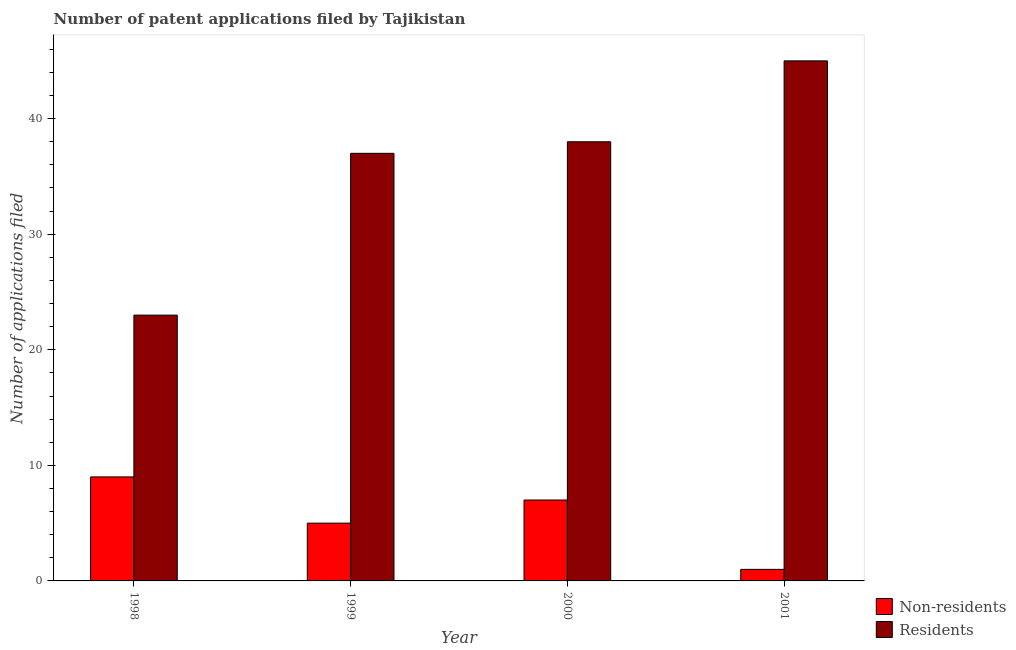How many different coloured bars are there?
Make the answer very short. 2. How many groups of bars are there?
Ensure brevity in your answer.  4. Are the number of bars per tick equal to the number of legend labels?
Ensure brevity in your answer.  Yes. How many bars are there on the 3rd tick from the left?
Give a very brief answer. 2. How many bars are there on the 4th tick from the right?
Make the answer very short. 2. What is the label of the 4th group of bars from the left?
Provide a short and direct response. 2001. What is the number of patent applications by non residents in 2001?
Your answer should be very brief. 1. Across all years, what is the maximum number of patent applications by non residents?
Ensure brevity in your answer.  9. Across all years, what is the minimum number of patent applications by non residents?
Provide a short and direct response. 1. In which year was the number of patent applications by non residents maximum?
Your answer should be very brief. 1998. In which year was the number of patent applications by residents minimum?
Provide a short and direct response. 1998. What is the total number of patent applications by residents in the graph?
Provide a succinct answer. 143. What is the difference between the number of patent applications by residents in 1998 and that in 2001?
Keep it short and to the point. -22. What is the difference between the number of patent applications by residents in 2000 and the number of patent applications by non residents in 2001?
Make the answer very short. -7. What is the average number of patent applications by non residents per year?
Give a very brief answer. 5.5. In the year 2001, what is the difference between the number of patent applications by non residents and number of patent applications by residents?
Your response must be concise. 0. Is the number of patent applications by non residents in 1998 less than that in 2001?
Offer a very short reply. No. Is the difference between the number of patent applications by residents in 1998 and 1999 greater than the difference between the number of patent applications by non residents in 1998 and 1999?
Keep it short and to the point. No. What is the difference between the highest and the second highest number of patent applications by residents?
Keep it short and to the point. 7. What is the difference between the highest and the lowest number of patent applications by residents?
Your answer should be compact. 22. What does the 1st bar from the left in 1999 represents?
Your response must be concise. Non-residents. What does the 2nd bar from the right in 2000 represents?
Offer a very short reply. Non-residents. Does the graph contain any zero values?
Your answer should be very brief. No. Does the graph contain grids?
Offer a very short reply. No. Where does the legend appear in the graph?
Provide a succinct answer. Bottom right. How many legend labels are there?
Offer a very short reply. 2. What is the title of the graph?
Offer a very short reply. Number of patent applications filed by Tajikistan. What is the label or title of the Y-axis?
Give a very brief answer. Number of applications filed. What is the Number of applications filed of Non-residents in 1998?
Provide a succinct answer. 9. What is the Number of applications filed in Residents in 1998?
Offer a very short reply. 23. What is the Number of applications filed in Non-residents in 1999?
Offer a terse response. 5. What is the Number of applications filed of Non-residents in 2000?
Ensure brevity in your answer.  7. What is the Number of applications filed of Residents in 2000?
Offer a terse response. 38. What is the total Number of applications filed in Residents in the graph?
Give a very brief answer. 143. What is the difference between the Number of applications filed in Non-residents in 1998 and that in 1999?
Offer a very short reply. 4. What is the difference between the Number of applications filed in Residents in 1998 and that in 1999?
Your answer should be very brief. -14. What is the difference between the Number of applications filed of Non-residents in 1999 and that in 2000?
Your response must be concise. -2. What is the difference between the Number of applications filed of Residents in 2000 and that in 2001?
Your answer should be compact. -7. What is the difference between the Number of applications filed in Non-residents in 1998 and the Number of applications filed in Residents in 2001?
Your answer should be very brief. -36. What is the difference between the Number of applications filed in Non-residents in 1999 and the Number of applications filed in Residents in 2000?
Give a very brief answer. -33. What is the difference between the Number of applications filed of Non-residents in 2000 and the Number of applications filed of Residents in 2001?
Ensure brevity in your answer.  -38. What is the average Number of applications filed in Non-residents per year?
Your answer should be compact. 5.5. What is the average Number of applications filed in Residents per year?
Keep it short and to the point. 35.75. In the year 1998, what is the difference between the Number of applications filed of Non-residents and Number of applications filed of Residents?
Provide a succinct answer. -14. In the year 1999, what is the difference between the Number of applications filed of Non-residents and Number of applications filed of Residents?
Offer a very short reply. -32. In the year 2000, what is the difference between the Number of applications filed in Non-residents and Number of applications filed in Residents?
Provide a short and direct response. -31. In the year 2001, what is the difference between the Number of applications filed in Non-residents and Number of applications filed in Residents?
Offer a very short reply. -44. What is the ratio of the Number of applications filed in Residents in 1998 to that in 1999?
Keep it short and to the point. 0.62. What is the ratio of the Number of applications filed in Non-residents in 1998 to that in 2000?
Keep it short and to the point. 1.29. What is the ratio of the Number of applications filed in Residents in 1998 to that in 2000?
Your answer should be compact. 0.61. What is the ratio of the Number of applications filed in Residents in 1998 to that in 2001?
Provide a short and direct response. 0.51. What is the ratio of the Number of applications filed in Non-residents in 1999 to that in 2000?
Your answer should be very brief. 0.71. What is the ratio of the Number of applications filed of Residents in 1999 to that in 2000?
Your response must be concise. 0.97. What is the ratio of the Number of applications filed in Non-residents in 1999 to that in 2001?
Your answer should be compact. 5. What is the ratio of the Number of applications filed of Residents in 1999 to that in 2001?
Your response must be concise. 0.82. What is the ratio of the Number of applications filed in Residents in 2000 to that in 2001?
Offer a very short reply. 0.84. What is the difference between the highest and the second highest Number of applications filed of Residents?
Make the answer very short. 7. What is the difference between the highest and the lowest Number of applications filed of Non-residents?
Make the answer very short. 8. 